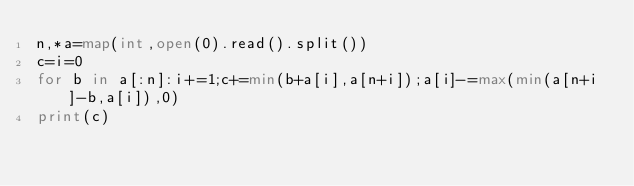<code> <loc_0><loc_0><loc_500><loc_500><_Python_>n,*a=map(int,open(0).read().split())
c=i=0
for b in a[:n]:i+=1;c+=min(b+a[i],a[n+i]);a[i]-=max(min(a[n+i]-b,a[i]),0)
print(c)</code> 